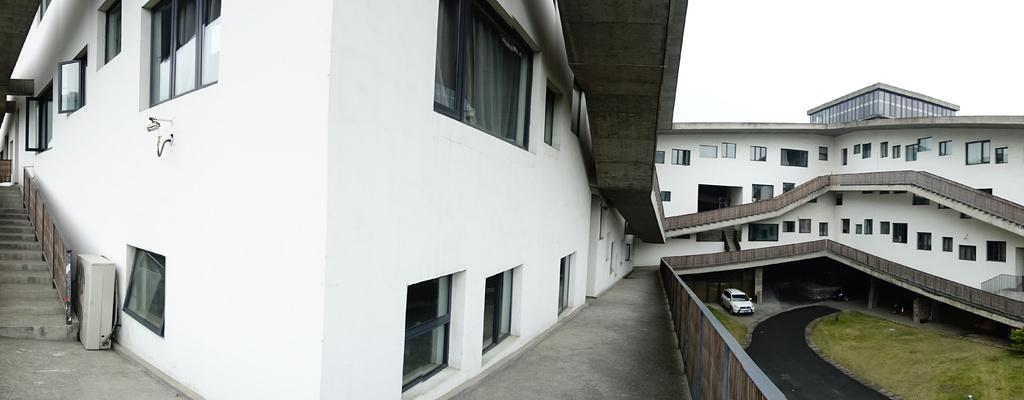What type of structure is present in the image? There is a building with windows in the image. What celestial objects can be seen in the image? Stars are visible in the image. What type of transportation is present in the image? There are vehicles in the image. What type of vegetation is present in the image? There is grass in the image. What part of the natural environment is visible in the image? The sky is visible in the background of the image. What time does the clock show in the image? There is no clock present in the image, so it is not possible to determine the time. 